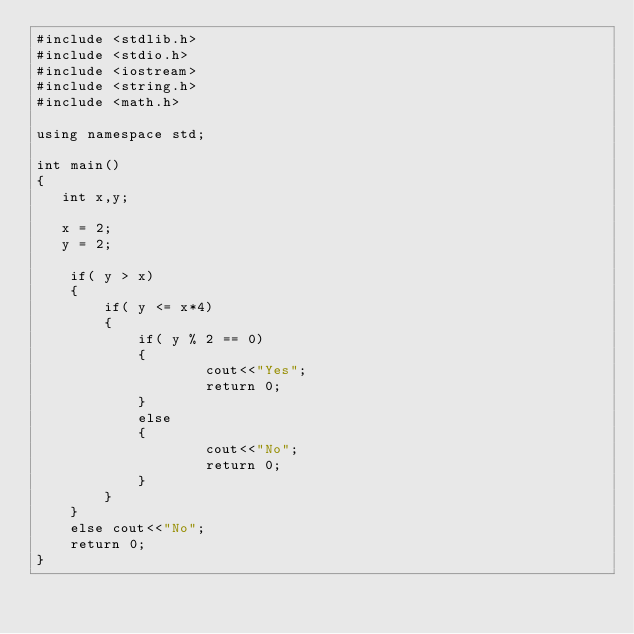Convert code to text. <code><loc_0><loc_0><loc_500><loc_500><_C++_>#include <stdlib.h> 
#include <stdio.h>
#include <iostream>
#include <string.h>
#include <math.h>

using namespace std; 

int main()
{
   int x,y;

   x = 2;
   y = 2;

    if( y > x)
    {    
        if( y <= x*4) 
        {
            if( y % 2 == 0)
            {
                    cout<<"Yes";
                    return 0;
            }
            else 
            {
                    cout<<"No";
                    return 0;
            }
        }
    }
    else cout<<"No";
    return 0;
}

</code> 